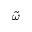<formula> <loc_0><loc_0><loc_500><loc_500>\widetilde { \omega }</formula> 